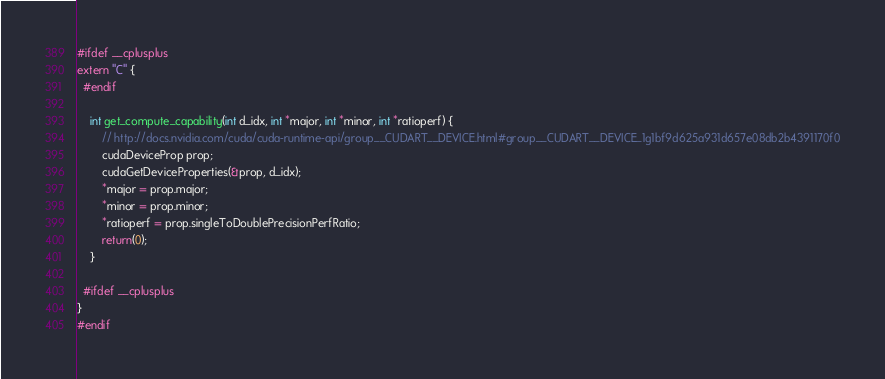Convert code to text. <code><loc_0><loc_0><loc_500><loc_500><_Cuda_>

#ifdef __cplusplus
extern "C" {
  #endif

    int get_compute_capability(int d_idx, int *major, int *minor, int *ratioperf) {
        // http://docs.nvidia.com/cuda/cuda-runtime-api/group__CUDART__DEVICE.html#group__CUDART__DEVICE_1g1bf9d625a931d657e08db2b4391170f0
        cudaDeviceProp prop;
        cudaGetDeviceProperties(&prop, d_idx);
        *major = prop.major;
        *minor = prop.minor;
        *ratioperf = prop.singleToDoublePrecisionPerfRatio;
        return(0);
    }

  #ifdef __cplusplus
}
#endif
</code> 